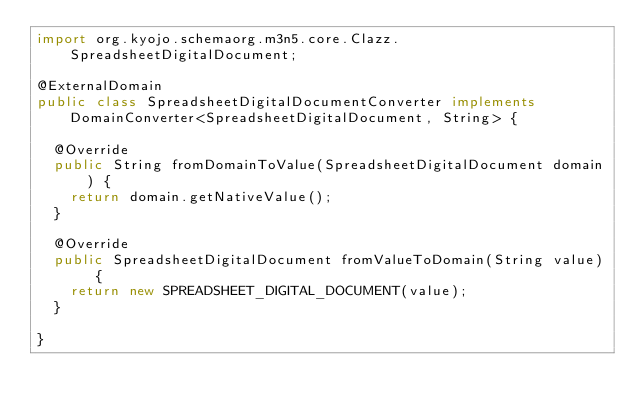Convert code to text. <code><loc_0><loc_0><loc_500><loc_500><_Java_>import org.kyojo.schemaorg.m3n5.core.Clazz.SpreadsheetDigitalDocument;

@ExternalDomain
public class SpreadsheetDigitalDocumentConverter implements DomainConverter<SpreadsheetDigitalDocument, String> {

	@Override
	public String fromDomainToValue(SpreadsheetDigitalDocument domain) {
		return domain.getNativeValue();
	}

	@Override
	public SpreadsheetDigitalDocument fromValueToDomain(String value) {
		return new SPREADSHEET_DIGITAL_DOCUMENT(value);
	}

}
</code> 